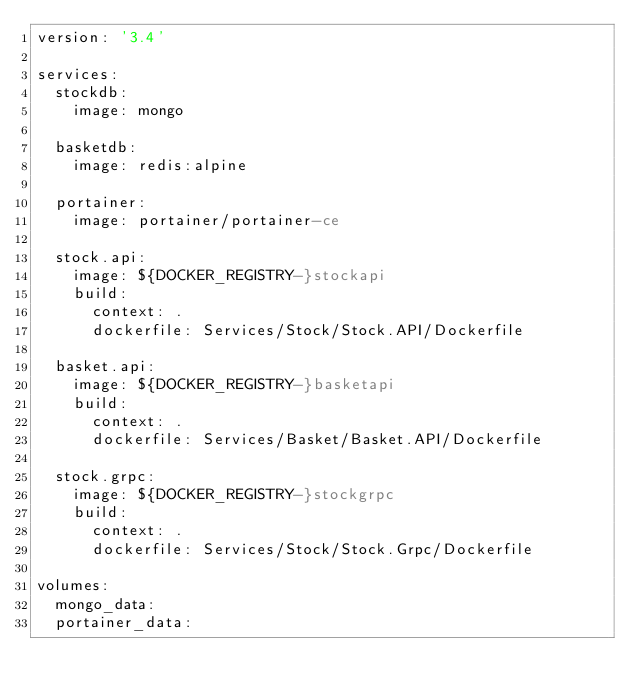<code> <loc_0><loc_0><loc_500><loc_500><_YAML_>version: '3.4'

services:
  stockdb:
    image: mongo
  
  basketdb:
    image: redis:alpine

  portainer:
    image: portainer/portainer-ce

  stock.api:
    image: ${DOCKER_REGISTRY-}stockapi
    build:
      context: .
      dockerfile: Services/Stock/Stock.API/Dockerfile

  basket.api:
    image: ${DOCKER_REGISTRY-}basketapi
    build:
      context: .
      dockerfile: Services/Basket/Basket.API/Dockerfile

  stock.grpc:
    image: ${DOCKER_REGISTRY-}stockgrpc
    build:
      context: .
      dockerfile: Services/Stock/Stock.Grpc/Dockerfile

volumes:
  mongo_data:  
  portainer_data:

</code> 